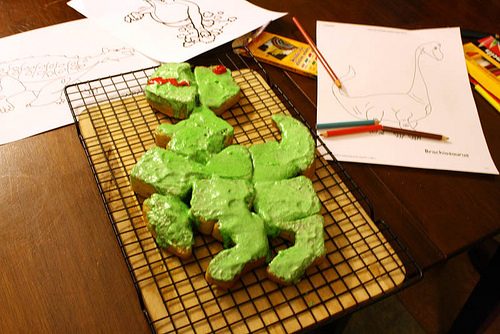<image>
Is there a cake on the table? Yes. Looking at the image, I can see the cake is positioned on top of the table, with the table providing support. Is the cake on the cutting board? Yes. Looking at the image, I can see the cake is positioned on top of the cutting board, with the cutting board providing support. 